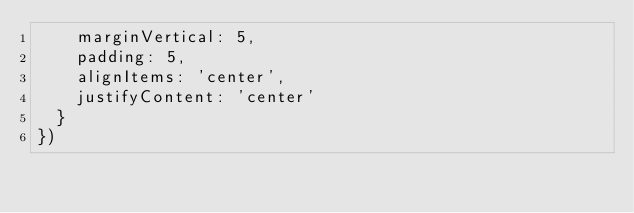Convert code to text. <code><loc_0><loc_0><loc_500><loc_500><_JavaScript_>    marginVertical: 5,
    padding: 5,
    alignItems: 'center',
    justifyContent: 'center'
  }
})</code> 